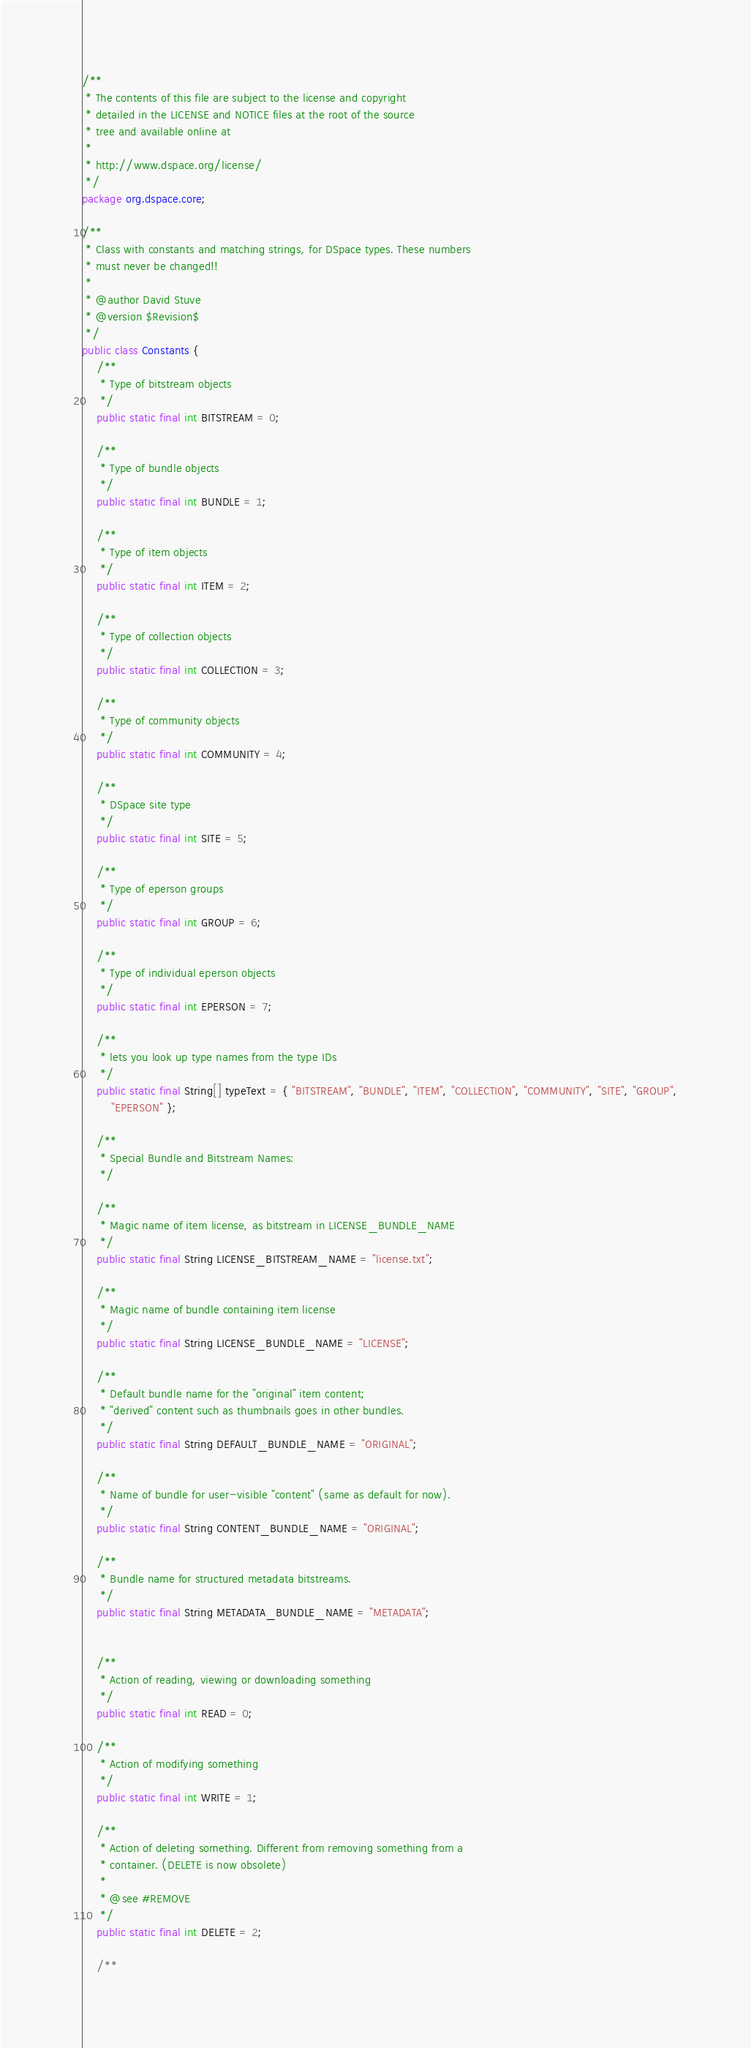Convert code to text. <code><loc_0><loc_0><loc_500><loc_500><_Java_>/**
 * The contents of this file are subject to the license and copyright
 * detailed in the LICENSE and NOTICE files at the root of the source
 * tree and available online at
 *
 * http://www.dspace.org/license/
 */
package org.dspace.core;

/**
 * Class with constants and matching strings, for DSpace types. These numbers
 * must never be changed!!
 *
 * @author David Stuve
 * @version $Revision$
 */
public class Constants {
    /**
     * Type of bitstream objects
     */
    public static final int BITSTREAM = 0;

    /**
     * Type of bundle objects
     */
    public static final int BUNDLE = 1;

    /**
     * Type of item objects
     */
    public static final int ITEM = 2;

    /**
     * Type of collection objects
     */
    public static final int COLLECTION = 3;

    /**
     * Type of community objects
     */
    public static final int COMMUNITY = 4;

    /**
     * DSpace site type
     */
    public static final int SITE = 5;

    /**
     * Type of eperson groups
     */
    public static final int GROUP = 6;

    /**
     * Type of individual eperson objects
     */
    public static final int EPERSON = 7;

    /**
     * lets you look up type names from the type IDs
     */
    public static final String[] typeText = { "BITSTREAM", "BUNDLE", "ITEM", "COLLECTION", "COMMUNITY", "SITE", "GROUP",
        "EPERSON" };

    /**
     * Special Bundle and Bitstream Names:
     */

    /**
     * Magic name of item license, as bitstream in LICENSE_BUNDLE_NAME
     */
    public static final String LICENSE_BITSTREAM_NAME = "license.txt";

    /**
     * Magic name of bundle containing item license
     */
    public static final String LICENSE_BUNDLE_NAME = "LICENSE";

    /**
     * Default bundle name for the "original" item content;
     * "derived" content such as thumbnails goes in other bundles.
     */
    public static final String DEFAULT_BUNDLE_NAME = "ORIGINAL";

    /**
     * Name of bundle for user-visible "content" (same as default for now).
     */
    public static final String CONTENT_BUNDLE_NAME = "ORIGINAL";

    /**
     * Bundle name for structured metadata bitstreams.
     */
    public static final String METADATA_BUNDLE_NAME = "METADATA";


    /**
     * Action of reading, viewing or downloading something
     */
    public static final int READ = 0;

    /**
     * Action of modifying something
     */
    public static final int WRITE = 1;

    /**
     * Action of deleting something. Different from removing something from a
     * container. (DELETE is now obsolete)
     *
     * @see #REMOVE
     */
    public static final int DELETE = 2;

    /**</code> 